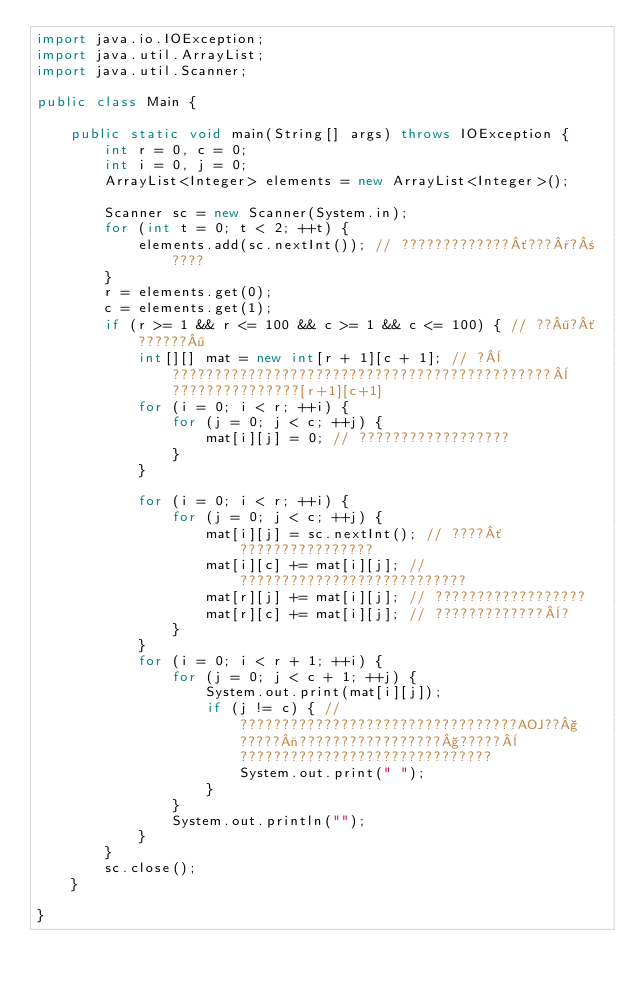Convert code to text. <code><loc_0><loc_0><loc_500><loc_500><_Java_>import java.io.IOException;
import java.util.ArrayList;
import java.util.Scanner;

public class Main {

	public static void main(String[] args) throws IOException {
		int r = 0, c = 0;
		int i = 0, j = 0;
		ArrayList<Integer> elements = new ArrayList<Integer>();

		Scanner sc = new Scanner(System.in);
		for (int t = 0; t < 2; ++t) {
			elements.add(sc.nextInt()); // ?????????????´???°?±????
		}
		r = elements.get(0);
		c = elements.get(1);
		if (r >= 1 && r <= 100 && c >= 1 && c <= 100) { // ??¶?´??????¶
			int[][] mat = new int[r + 1][c + 1]; // ?¨?????????????????????????????????????????????¨???????????????[r+1][c+1]
			for (i = 0; i < r; ++i) {
				for (j = 0; j < c; ++j) {
					mat[i][j] = 0; // ??????????????????
				}
			}

			for (i = 0; i < r; ++i) {
				for (j = 0; j < c; ++j) {
					mat[i][j] = sc.nextInt(); // ????´????????????????
					mat[i][c] += mat[i][j]; // ???????????????????????????
					mat[r][j] += mat[i][j]; // ??????????????????
					mat[r][c] += mat[i][j]; // ?????????????¨?
				}
			}
			for (i = 0; i < r + 1; ++i) {
				for (j = 0; j < c + 1; ++j) {
					System.out.print(mat[i][j]);
					if (j != c) { // ?????????????????????????????????AOJ??§?????¬?????????????????§?????¨??????????????????????????????
						System.out.print(" ");
					}
				}
				System.out.println("");
			}
		}
		sc.close();
	}

}</code> 